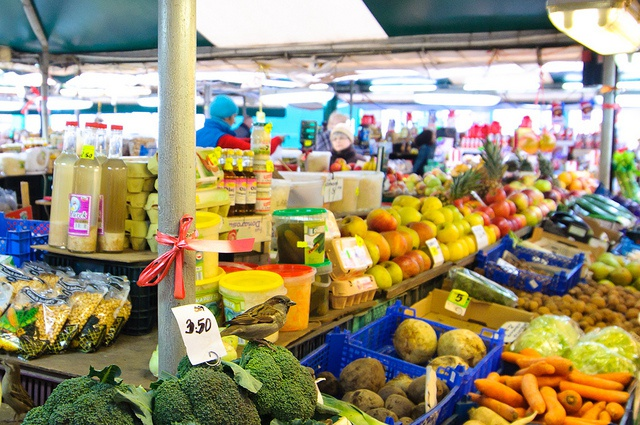Describe the objects in this image and their specific colors. I can see carrot in teal, orange, red, and maroon tones, broccoli in teal, black, and darkgreen tones, broccoli in teal, darkgreen, black, and olive tones, broccoli in teal, black, darkgreen, and green tones, and bottle in teal, tan, lightgray, and khaki tones in this image. 